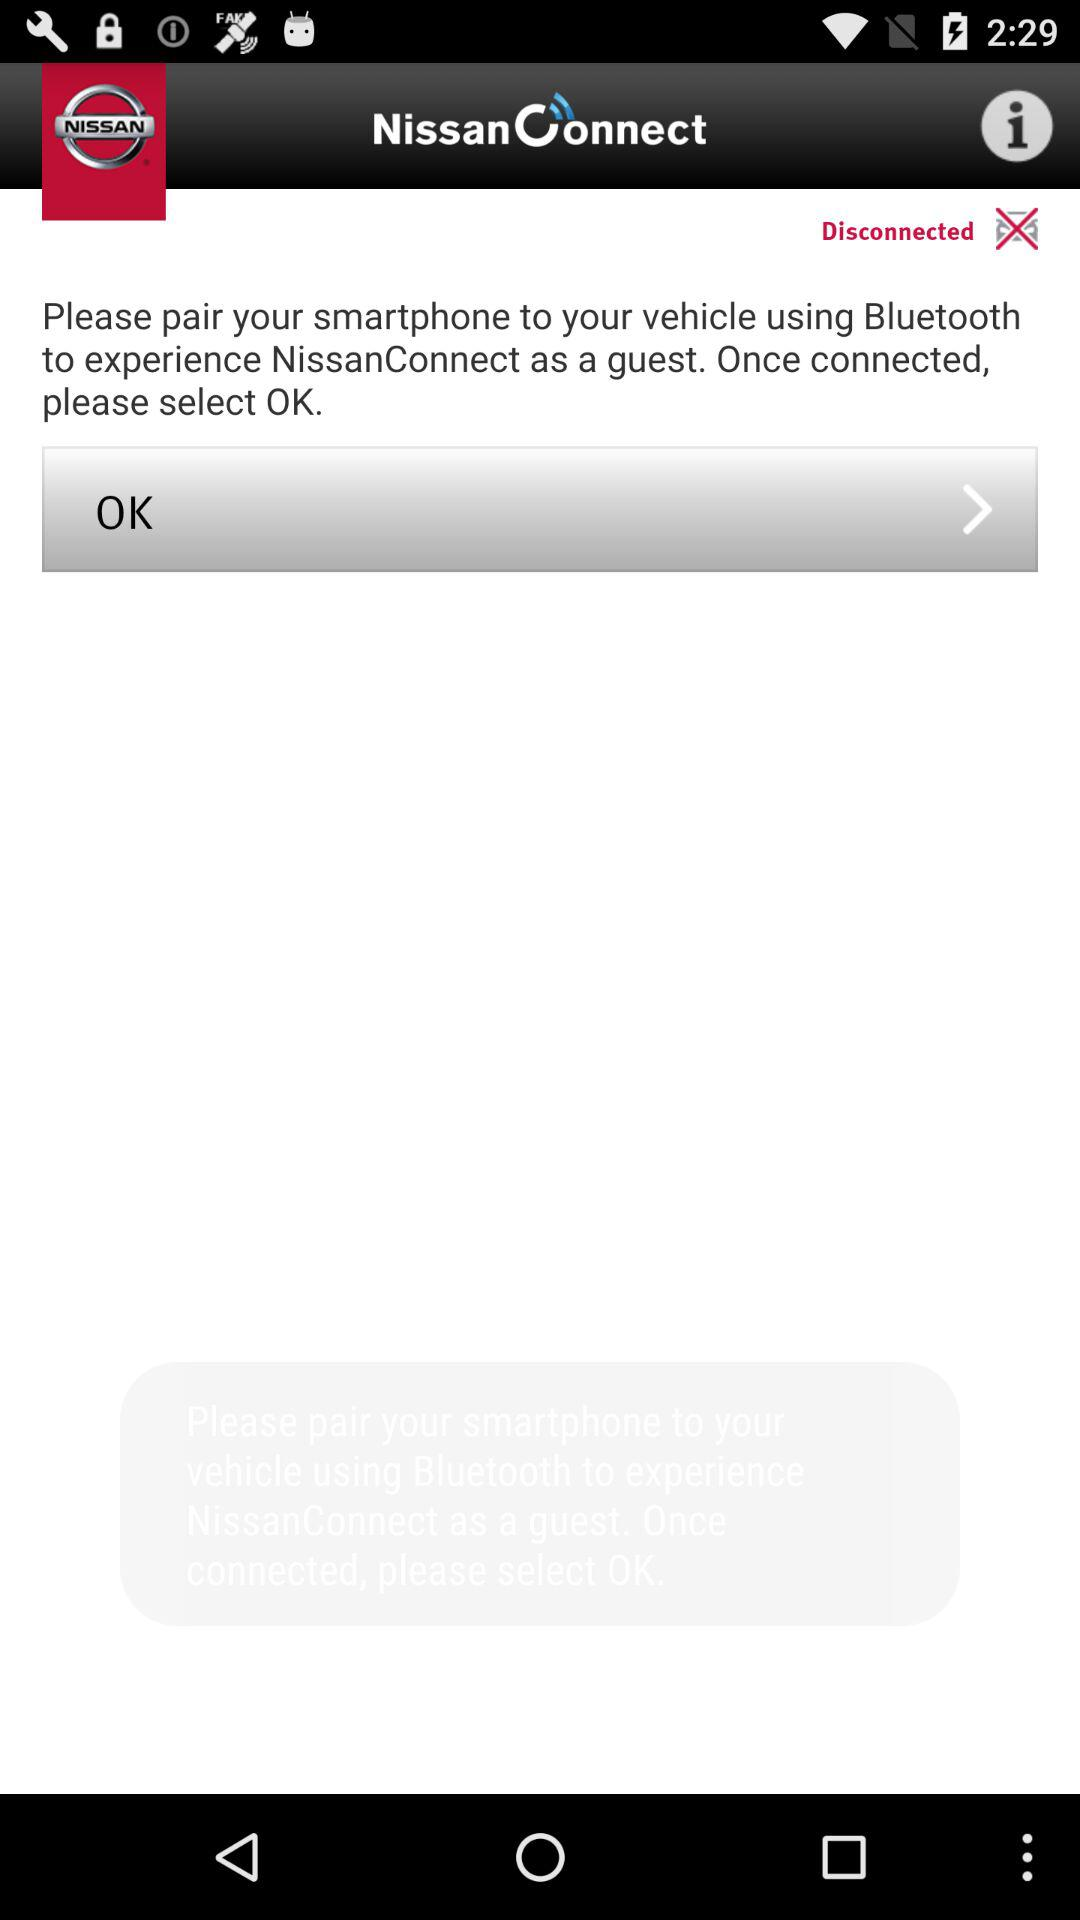What is the app name? The name of the app is "NissanConnect". 